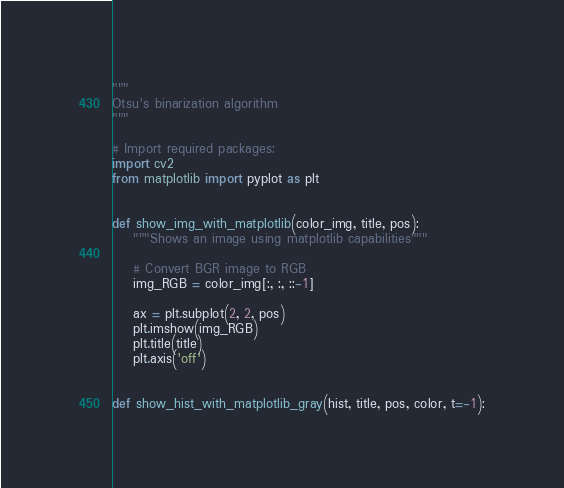<code> <loc_0><loc_0><loc_500><loc_500><_Python_>"""
Otsu's binarization algorithm
"""

# Import required packages:
import cv2
from matplotlib import pyplot as plt


def show_img_with_matplotlib(color_img, title, pos):
    """Shows an image using matplotlib capabilities"""

    # Convert BGR image to RGB
    img_RGB = color_img[:, :, ::-1]

    ax = plt.subplot(2, 2, pos)
    plt.imshow(img_RGB)
    plt.title(title)
    plt.axis('off')


def show_hist_with_matplotlib_gray(hist, title, pos, color, t=-1):</code> 